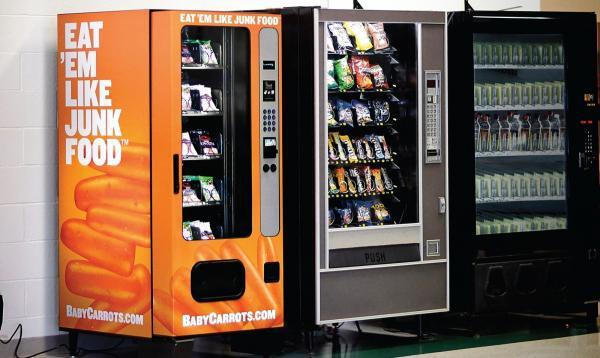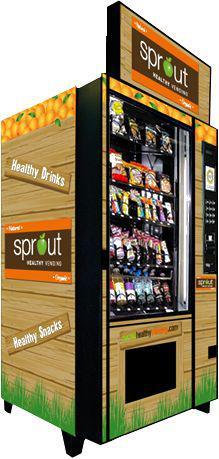The first image is the image on the left, the second image is the image on the right. For the images shown, is this caption "In one of the images, at least three vending machines are lined up together." true? Answer yes or no. Yes. 